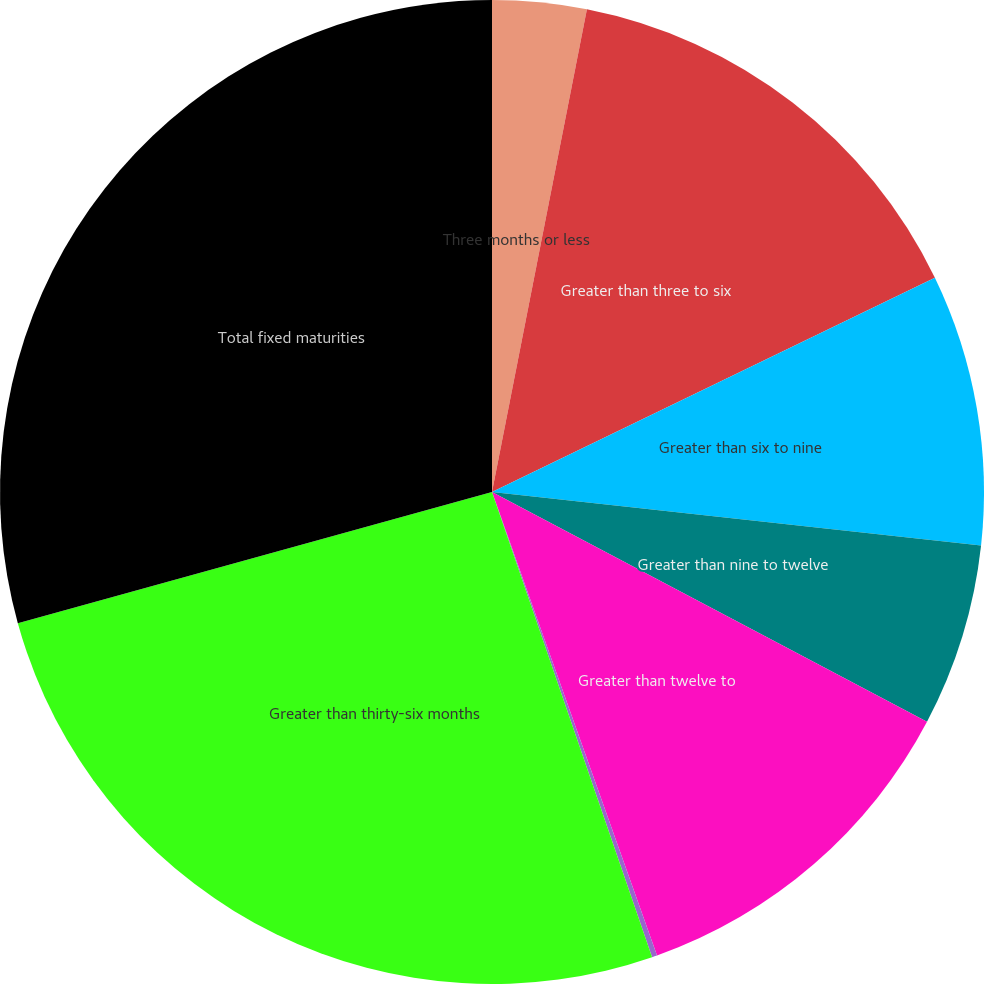Convert chart. <chart><loc_0><loc_0><loc_500><loc_500><pie_chart><fcel>Three months or less<fcel>Greater than three to six<fcel>Greater than six to nine<fcel>Greater than nine to twelve<fcel>Greater than twelve to<fcel>Greater than twenty-four to<fcel>Greater than thirty-six months<fcel>Total fixed maturities<nl><fcel>3.09%<fcel>14.74%<fcel>8.91%<fcel>6.0%<fcel>11.82%<fcel>0.17%<fcel>25.98%<fcel>29.3%<nl></chart> 